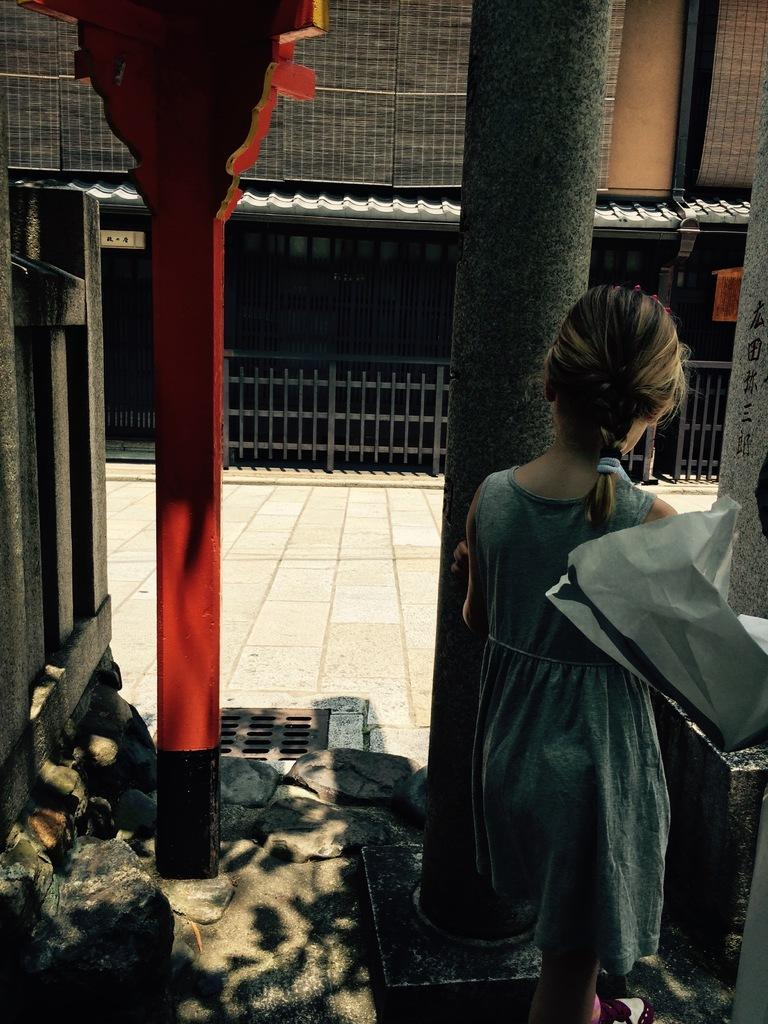What is the girl doing in the image? The girl is standing near a pillar in the image. What type of structure is visible in the image? There is a house in the image. What feature can be seen on the house? The house has grilles in front of it. What type of donkey can be seen using scissors to cut water in the image? There is no donkey, scissors, or water present in the image. 